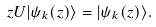<formula> <loc_0><loc_0><loc_500><loc_500>z U | \psi _ { k } ( z ) \rangle = | \psi _ { k } ( z ) \rangle .</formula> 